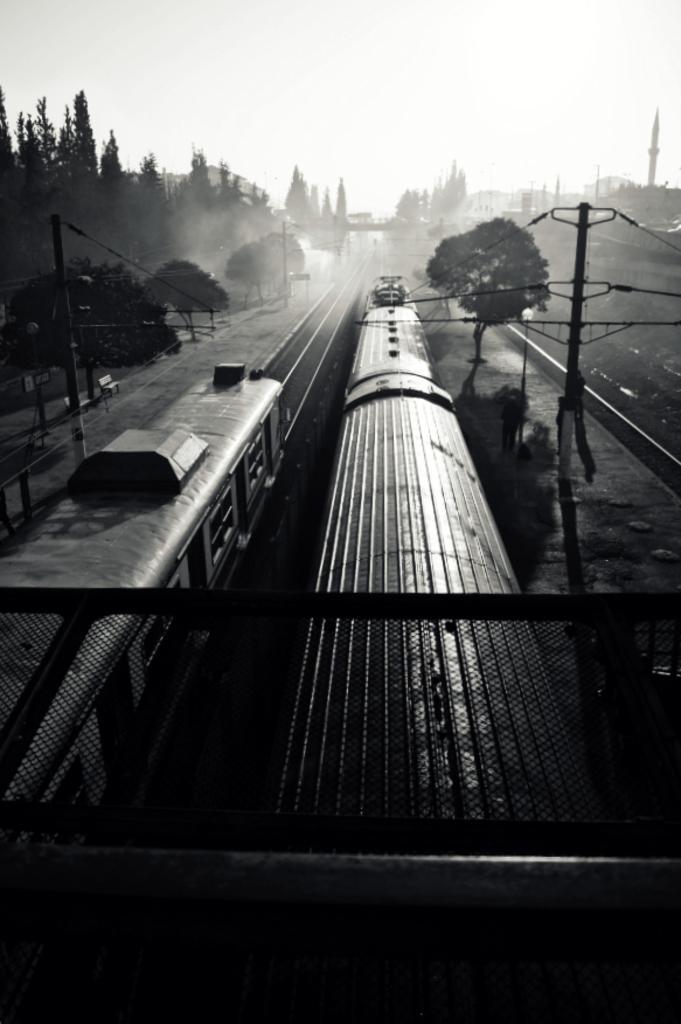Please provide a concise description of this image. In this picture I can see there is a trains passing on the track and there are some trees and electric poles and the sky is clear. 